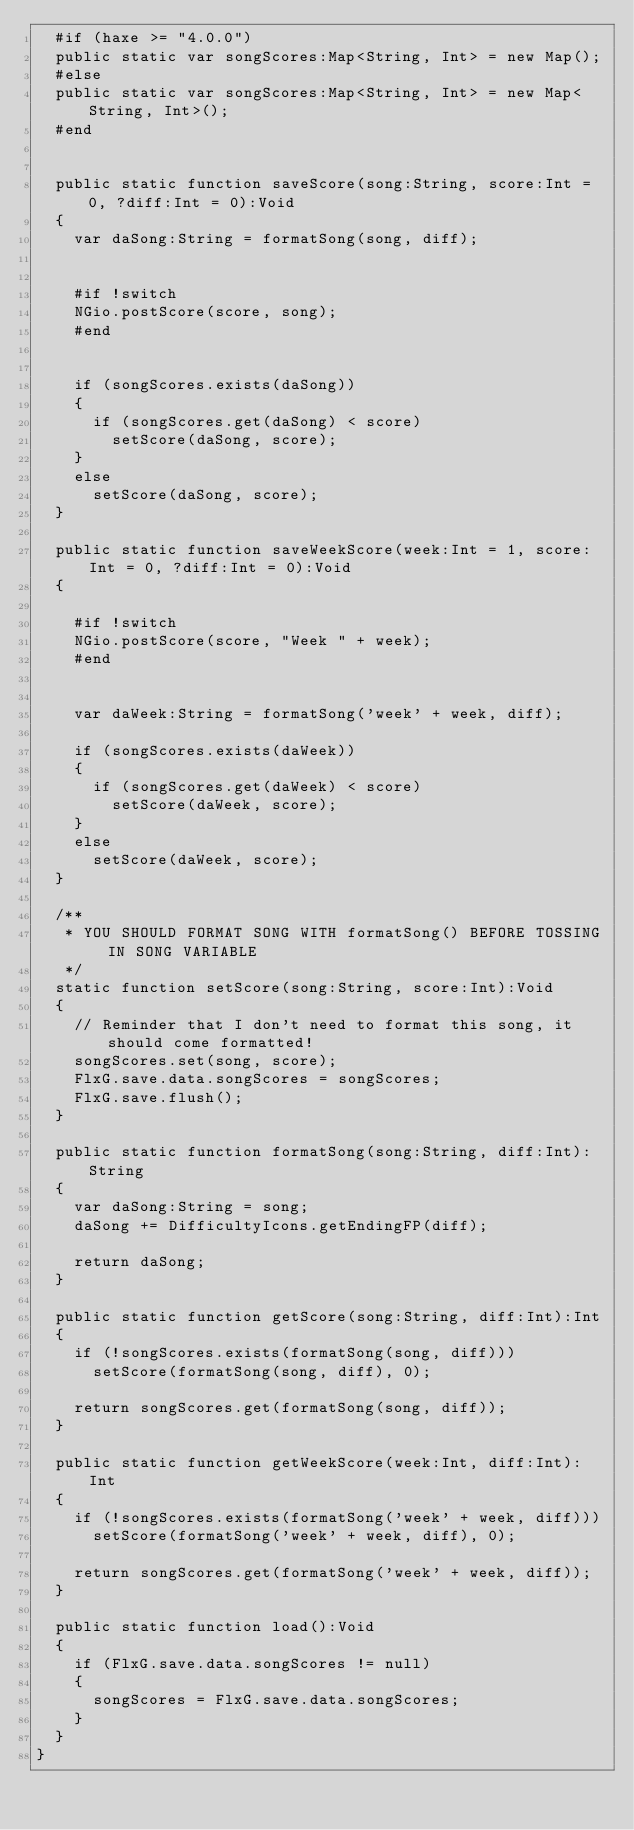<code> <loc_0><loc_0><loc_500><loc_500><_Haxe_>	#if (haxe >= "4.0.0")
	public static var songScores:Map<String, Int> = new Map();
	#else
	public static var songScores:Map<String, Int> = new Map<String, Int>();
	#end


	public static function saveScore(song:String, score:Int = 0, ?diff:Int = 0):Void
	{
		var daSong:String = formatSong(song, diff);


		#if !switch
		NGio.postScore(score, song);
		#end


		if (songScores.exists(daSong))
		{
			if (songScores.get(daSong) < score)
				setScore(daSong, score);
		}
		else
			setScore(daSong, score);
	}

	public static function saveWeekScore(week:Int = 1, score:Int = 0, ?diff:Int = 0):Void
	{

		#if !switch
		NGio.postScore(score, "Week " + week);
		#end


		var daWeek:String = formatSong('week' + week, diff);

		if (songScores.exists(daWeek))
		{
			if (songScores.get(daWeek) < score)
				setScore(daWeek, score);
		}
		else
			setScore(daWeek, score);
	}

	/**
	 * YOU SHOULD FORMAT SONG WITH formatSong() BEFORE TOSSING IN SONG VARIABLE
	 */
	static function setScore(song:String, score:Int):Void
	{
		// Reminder that I don't need to format this song, it should come formatted!
		songScores.set(song, score);
		FlxG.save.data.songScores = songScores;
		FlxG.save.flush();
	}

	public static function formatSong(song:String, diff:Int):String
	{
		var daSong:String = song;
		daSong += DifficultyIcons.getEndingFP(diff);

		return daSong;
	}

	public static function getScore(song:String, diff:Int):Int
	{
		if (!songScores.exists(formatSong(song, diff)))
			setScore(formatSong(song, diff), 0);

		return songScores.get(formatSong(song, diff));
	}

	public static function getWeekScore(week:Int, diff:Int):Int
	{
		if (!songScores.exists(formatSong('week' + week, diff)))
			setScore(formatSong('week' + week, diff), 0);

		return songScores.get(formatSong('week' + week, diff));
	}

	public static function load():Void
	{
		if (FlxG.save.data.songScores != null)
		{
			songScores = FlxG.save.data.songScores;
		}
	}
}
</code> 